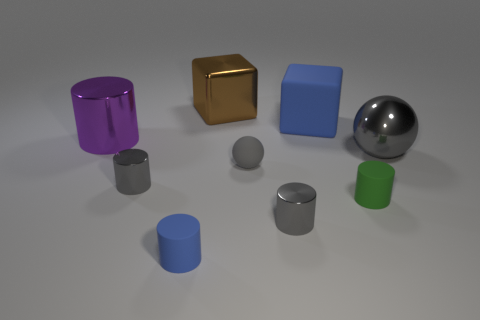Subtract all brown cylinders. Subtract all brown balls. How many cylinders are left? 5 Add 1 blue cylinders. How many objects exist? 10 Subtract all balls. How many objects are left? 7 Add 7 big gray shiny balls. How many big gray shiny balls are left? 8 Add 3 small blue objects. How many small blue objects exist? 4 Subtract 1 blue cubes. How many objects are left? 8 Subtract all small blue rubber cylinders. Subtract all small balls. How many objects are left? 7 